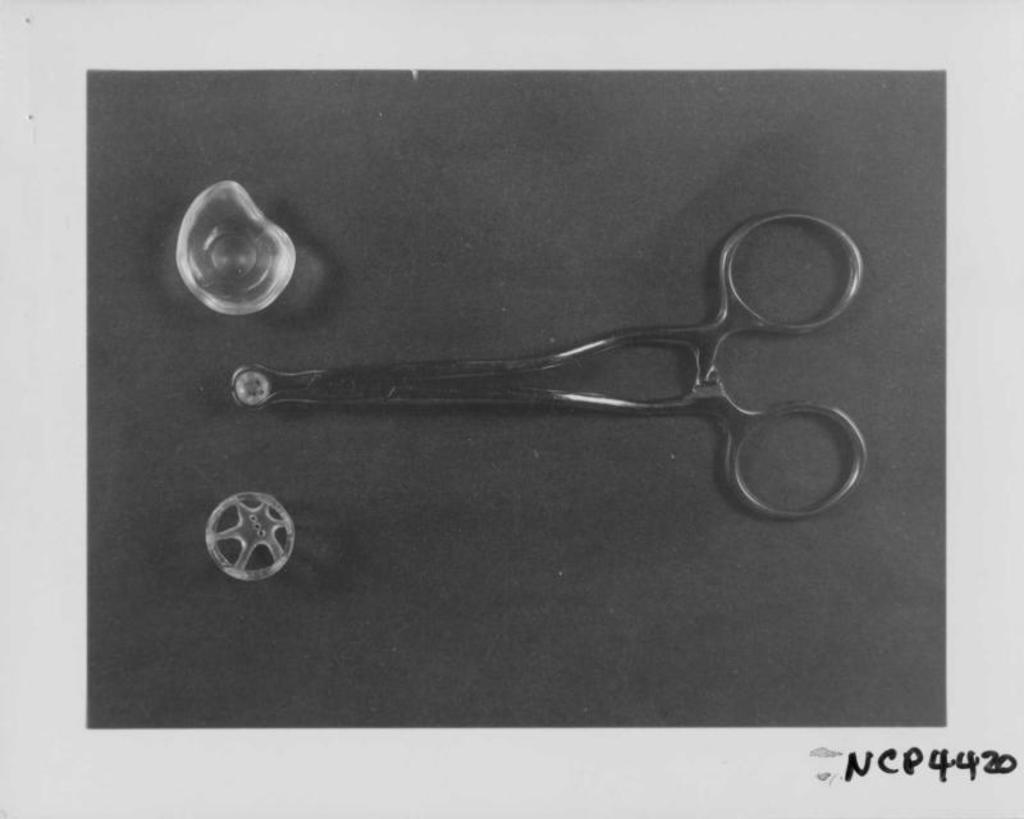What type of tool is visible in the image? There are scissors in the image. What other item can be seen in the image besides the scissors? There are rubber bands in the image. Is there any text or number present in the image? Yes, there is a number at the bottom right corner of the image. What type of polish is the mom applying to her nails in the image? There is no mom or nail polish present in the image. What causes the person in the image to laugh? There is no person laughing in the image, as it only features scissors, rubber bands, and a number. 